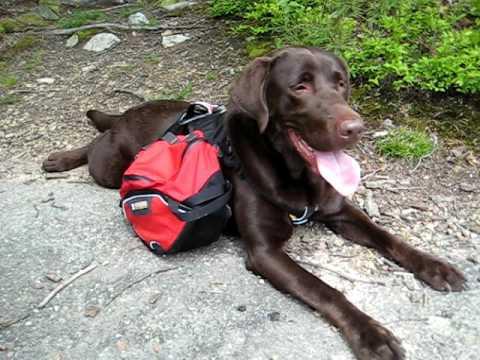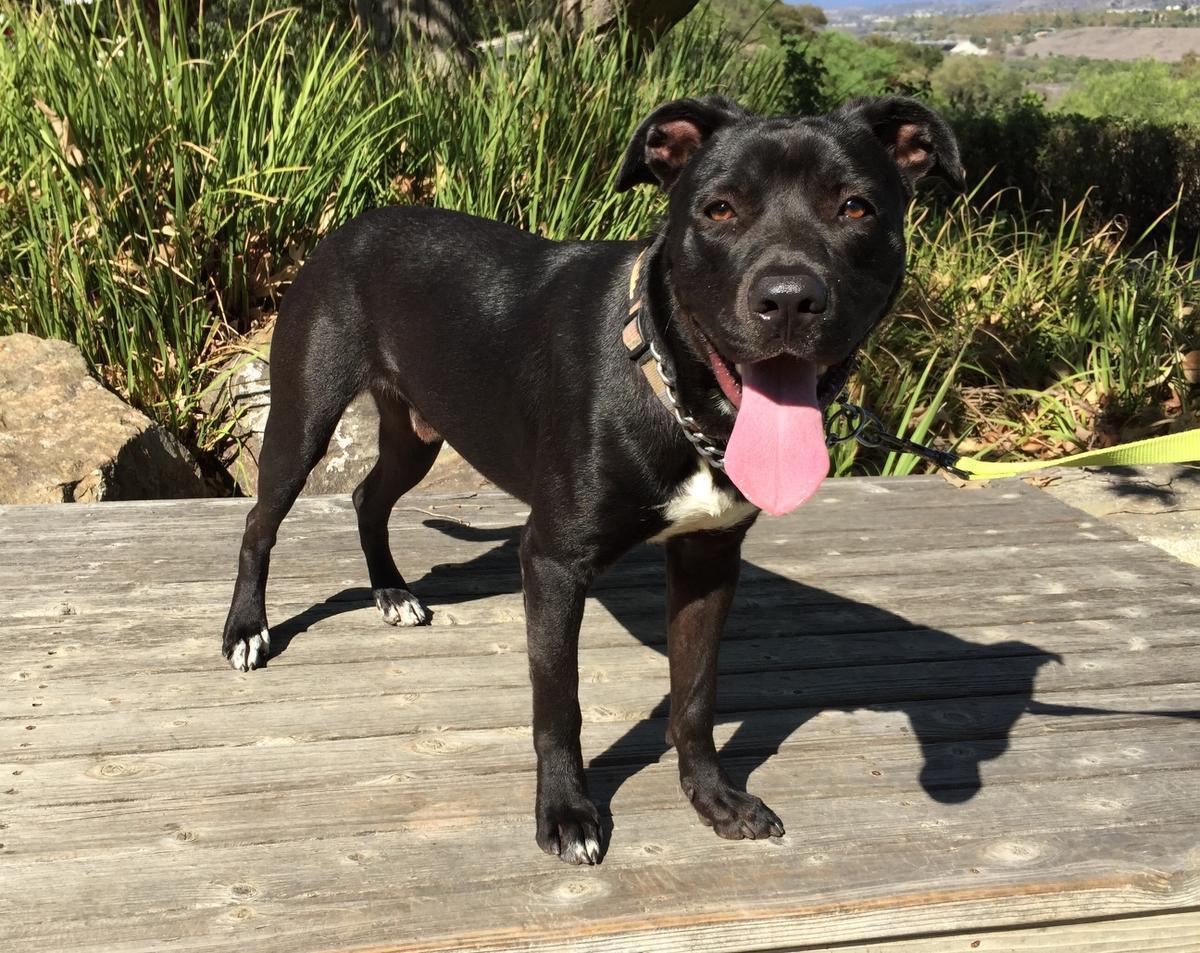The first image is the image on the left, the second image is the image on the right. Given the left and right images, does the statement "There is at least one dog wearing a red pack." hold true? Answer yes or no. Yes. The first image is the image on the left, the second image is the image on the right. Analyze the images presented: Is the assertion "The dog on the left is wearing a back pack" valid? Answer yes or no. Yes. 